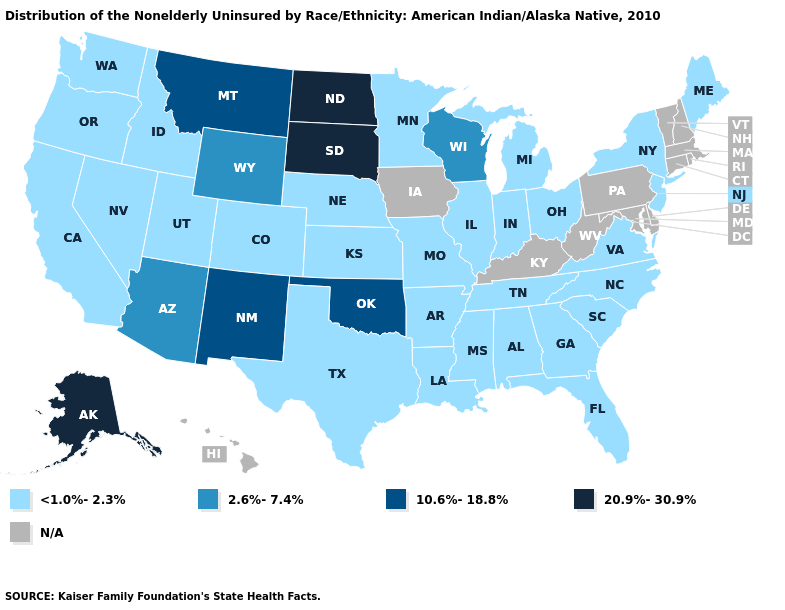What is the value of Rhode Island?
Quick response, please. N/A. What is the lowest value in states that border South Carolina?
Quick response, please. <1.0%-2.3%. What is the highest value in the Northeast ?
Be succinct. <1.0%-2.3%. What is the value of Texas?
Keep it brief. <1.0%-2.3%. What is the highest value in the South ?
Quick response, please. 10.6%-18.8%. Does Alaska have the lowest value in the USA?
Be succinct. No. Name the states that have a value in the range N/A?
Keep it brief. Connecticut, Delaware, Hawaii, Iowa, Kentucky, Maryland, Massachusetts, New Hampshire, Pennsylvania, Rhode Island, Vermont, West Virginia. Does California have the lowest value in the USA?
Quick response, please. Yes. Name the states that have a value in the range 2.6%-7.4%?
Concise answer only. Arizona, Wisconsin, Wyoming. Name the states that have a value in the range N/A?
Keep it brief. Connecticut, Delaware, Hawaii, Iowa, Kentucky, Maryland, Massachusetts, New Hampshire, Pennsylvania, Rhode Island, Vermont, West Virginia. Name the states that have a value in the range 2.6%-7.4%?
Concise answer only. Arizona, Wisconsin, Wyoming. Does Texas have the lowest value in the South?
Give a very brief answer. Yes. Among the states that border South Dakota , which have the highest value?
Write a very short answer. North Dakota. What is the value of Missouri?
Short answer required. <1.0%-2.3%. 